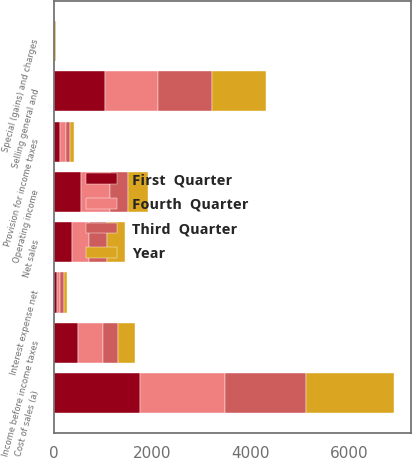<chart> <loc_0><loc_0><loc_500><loc_500><stacked_bar_chart><ecel><fcel>Net sales<fcel>Cost of sales (a)<fcel>Selling general and<fcel>Special (gains) and charges<fcel>Operating income<fcel>Interest expense net<fcel>Income before income taxes<fcel>Provision for income taxes<nl><fcel>Third  Quarter<fcel>359.35<fcel>1631.4<fcel>1088.2<fcel>6.3<fcel>371.5<fcel>66.1<fcel>305.4<fcel>73.4<nl><fcel>Year<fcel>359.35<fcel>1785.2<fcel>1093.3<fcel>26.2<fcel>412.5<fcel>65.3<fcel>347.2<fcel>83.6<nl><fcel>Fourth  Quarter<fcel>359.35<fcel>1737.2<fcel>1071.6<fcel>3.2<fcel>574.1<fcel>64.9<fcel>509.2<fcel>129.7<nl><fcel>First  Quarter<fcel>359.35<fcel>1745.1<fcel>1046.3<fcel>3.8<fcel>556.9<fcel>68.3<fcel>488.6<fcel>116.6<nl></chart> 